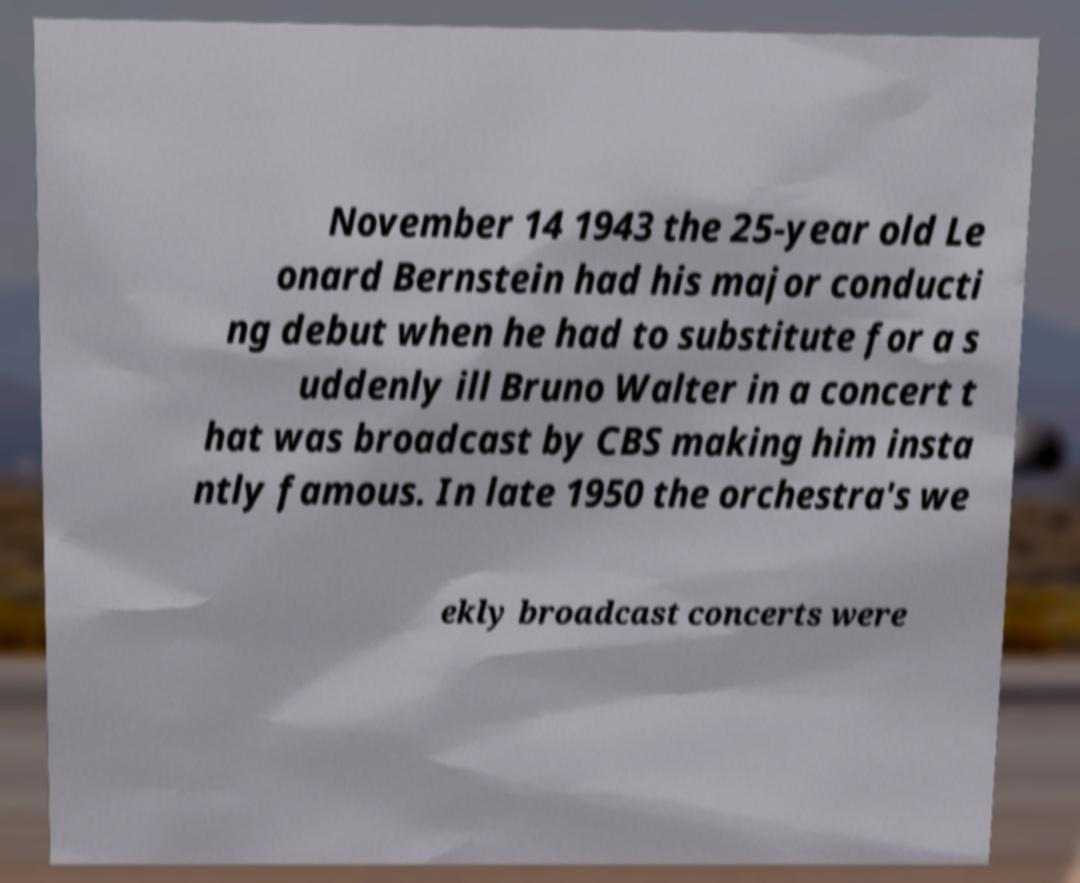Please read and relay the text visible in this image. What does it say? November 14 1943 the 25-year old Le onard Bernstein had his major conducti ng debut when he had to substitute for a s uddenly ill Bruno Walter in a concert t hat was broadcast by CBS making him insta ntly famous. In late 1950 the orchestra's we ekly broadcast concerts were 